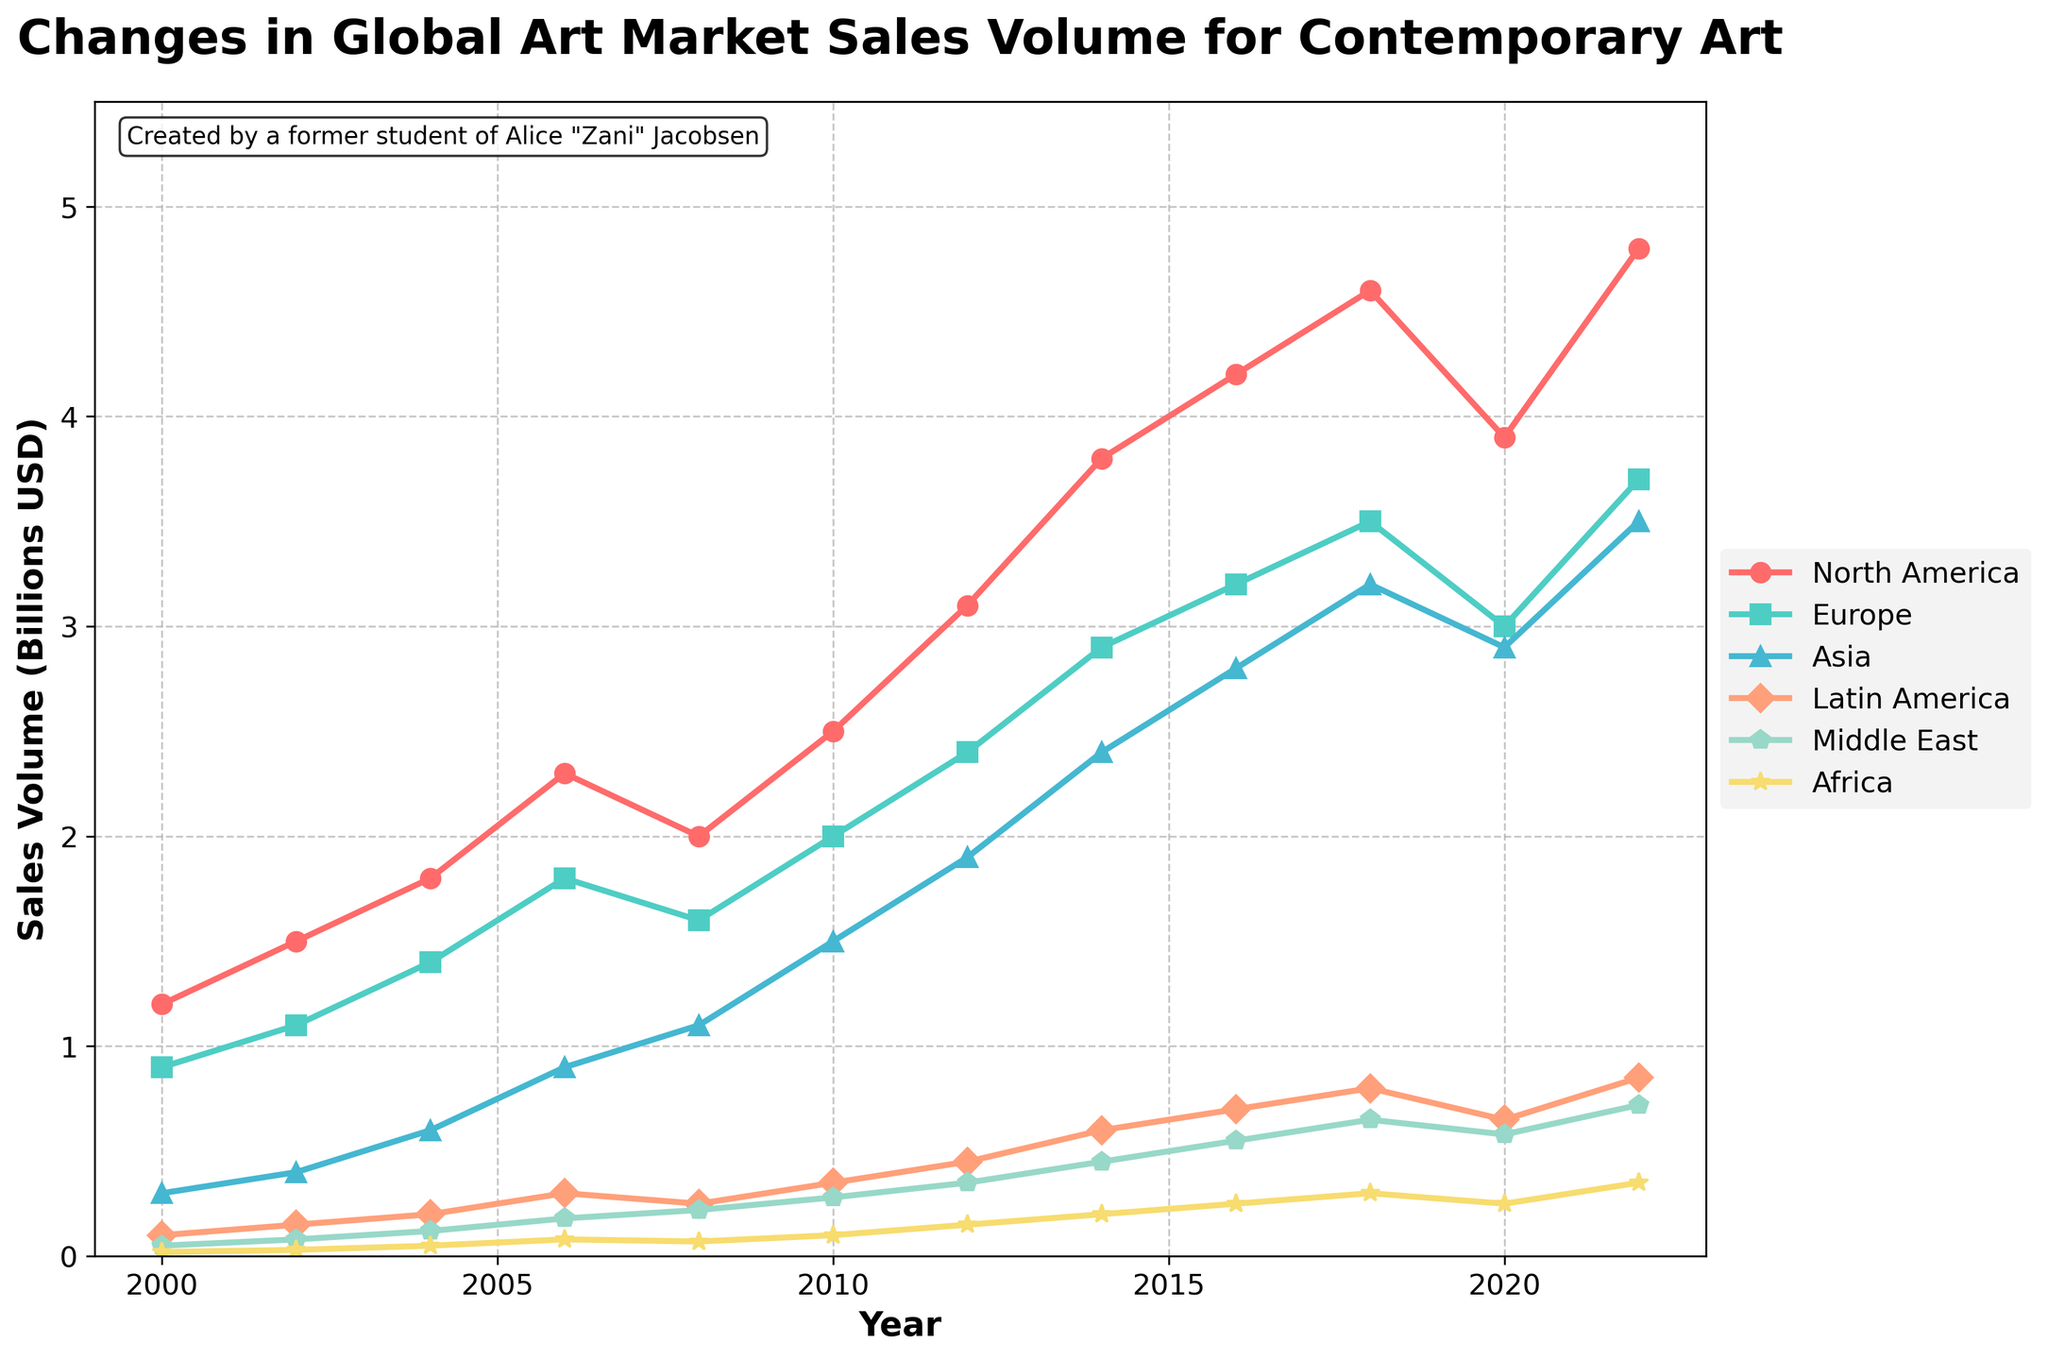Which region had the highest sales volume in 2022? From the figure, we can observe the data points corresponding to the year 2022 and compare the heights of the lines for each region. The North America line is the highest at 4.8 billion USD.
Answer: North America Which region showed the most significant overall increase in sales volume from 2000 to 2022? To determine this, we look at the beginning and end of each line for 2000 and 2022. North America increased from 1.2 billion in 2000 to 4.8 billion in 2022, which is the largest increase.
Answer: North America Between 2010 and 2020, which region had the least variation in sales volume? By visually inspecting the smoothness and the range of fluctuation in the lines between 2010 and 2020, we notice that Latin America seems to show the smallest change.
Answer: Latin America Which regions had a sales volume of more than 3 billion USD in 2018? We look at the 2018 data points and identify the lines above the 3 billion mark. North America, Europe, and Asia all had sales volumes above this threshold.
Answer: North America, Europe, Asia What is the combined sales volume of Europe and Asia in 2016? Extract the values from the figure for Europe (3.2 billion USD) and Asia (2.8 billion USD) in 2016, then add them together: 3.2 + 2.8 = 6 billion USD.
Answer: 6 billion USD Which year did Asia surpass 1 billion USD in sales volume? We look for the first year in Asia's line that crosses the 1 billion mark. This happens in 2008.
Answer: 2008 How did the Middle East's sales volume change from 2008 to 2010? By comparing the two values for the Middle East between 2008 (0.22 billion USD) and 2010 (0.28 billion USD), we observe an increase of 0.06 billion USD.
Answer: Increased by 0.06 billion USD Which region had a sales volume decline between 2018 and 2020? By comparing the data points for 2018 and 2020, North America is the only region where the sales volume decreased from 4.6 billion USD to 3.9 billion USD.
Answer: North America What was the sales volume difference between Europe and Latin America in 2020? Extract the values for Europe (3 billion USD) and Latin America (0.65 billion USD) in 2020 and calculate their difference: 3 - 0.65 = 2.35 billion USD.
Answer: 2.35 billion USD 